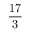Convert formula to latex. <formula><loc_0><loc_0><loc_500><loc_500>\frac { 1 7 } { 3 }</formula> 